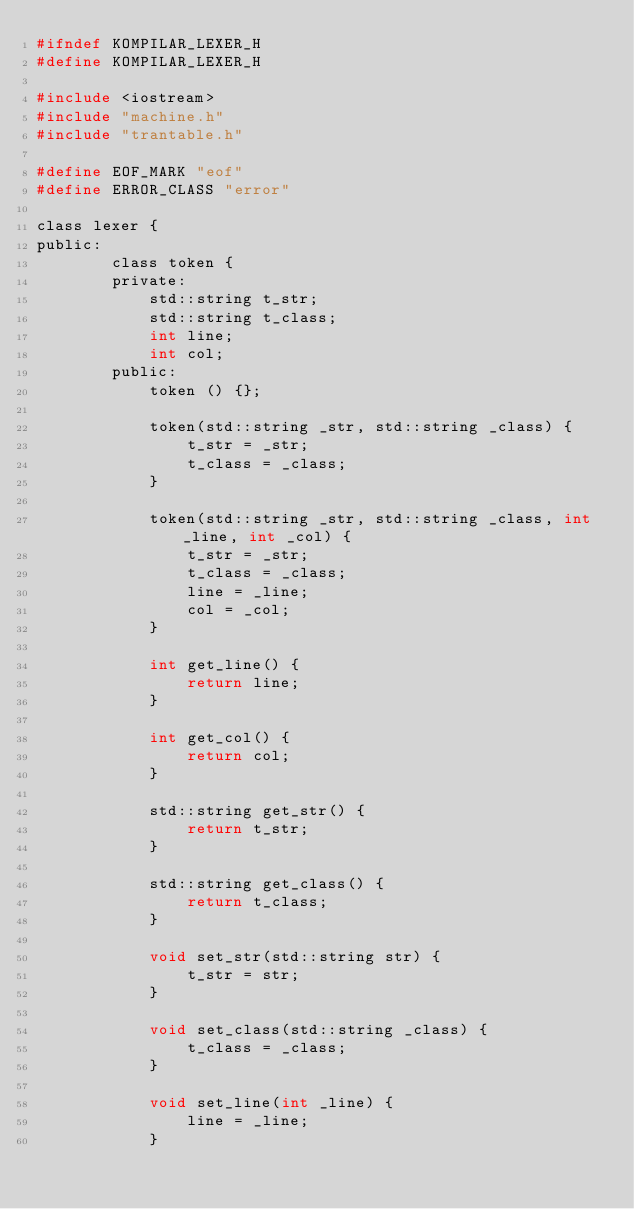<code> <loc_0><loc_0><loc_500><loc_500><_C_>#ifndef KOMPILAR_LEXER_H
#define KOMPILAR_LEXER_H

#include <iostream>
#include "machine.h"
#include "trantable.h"

#define EOF_MARK "eof"
#define ERROR_CLASS "error"

class lexer {
public:
        class token {
        private:
            std::string t_str;
            std::string t_class;
            int line;
            int col;
        public:
            token () {};

            token(std::string _str, std::string _class) {
                t_str = _str;
                t_class = _class;
            }

            token(std::string _str, std::string _class, int _line, int _col) {
                t_str = _str;
                t_class = _class;
                line = _line;
                col = _col;
            }

            int get_line() {
                return line;
            }

            int get_col() {
                return col;
            }

            std::string get_str() {
                return t_str;
            }

            std::string get_class() {
                return t_class;
            }

            void set_str(std::string str) {
                t_str = str;
            }

            void set_class(std::string _class) {
                t_class = _class;
            }

            void set_line(int _line) {
                line = _line;
            }
</code> 